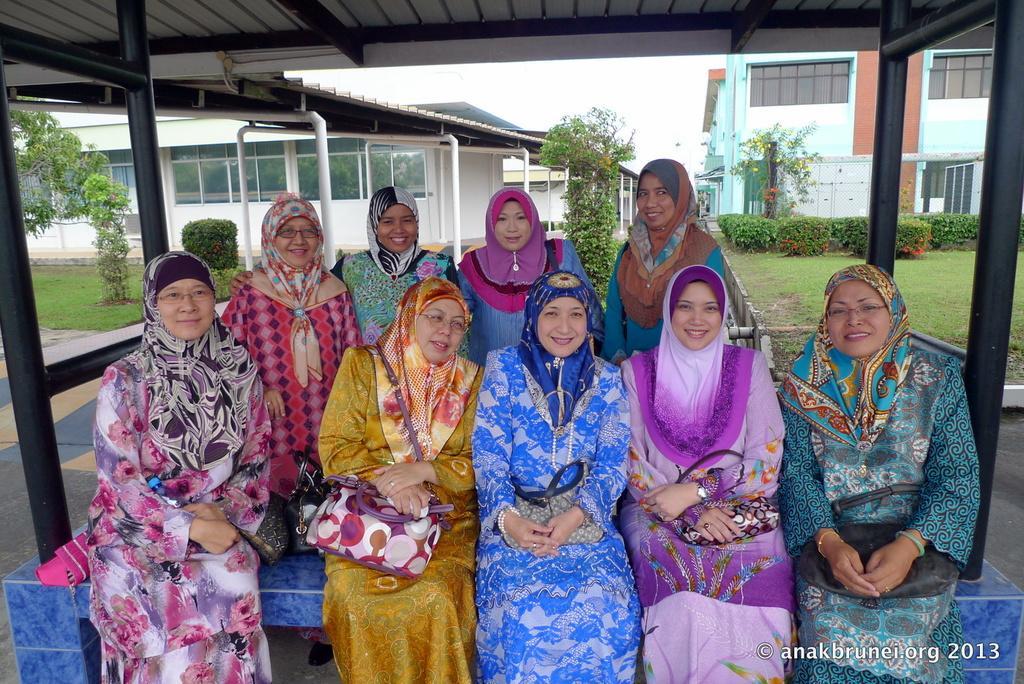Describe this image in one or two sentences. In this image there are group of people some of them are sitting and holding bags, and some of them are standing. And in the background there are buildings, trees, plants, grass and some poles. At the top there is ceiling and on the right side and left side there are some poles. 